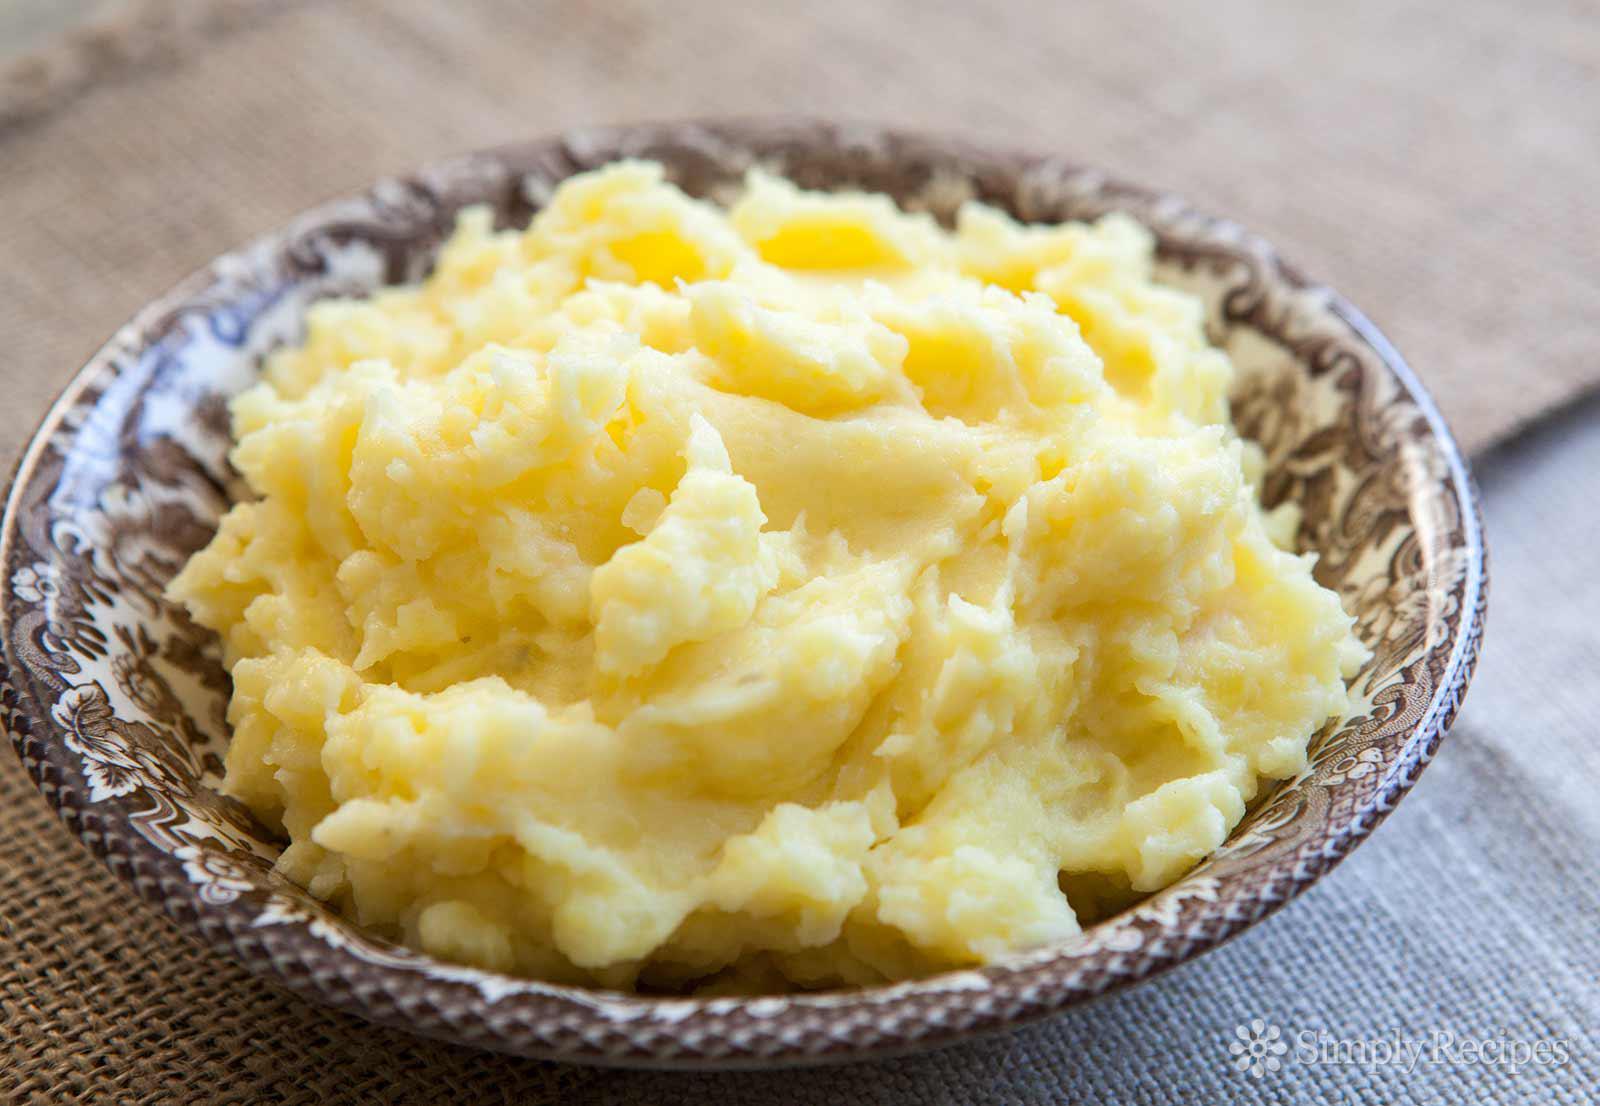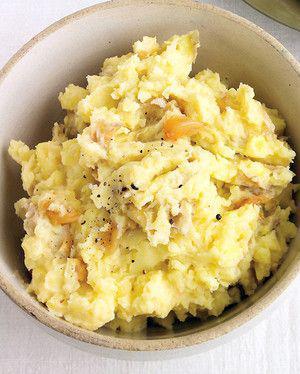The first image is the image on the left, the second image is the image on the right. Given the left and right images, does the statement "A utensil with a handle is in one round bowl of mashed potatoes." hold true? Answer yes or no. No. 